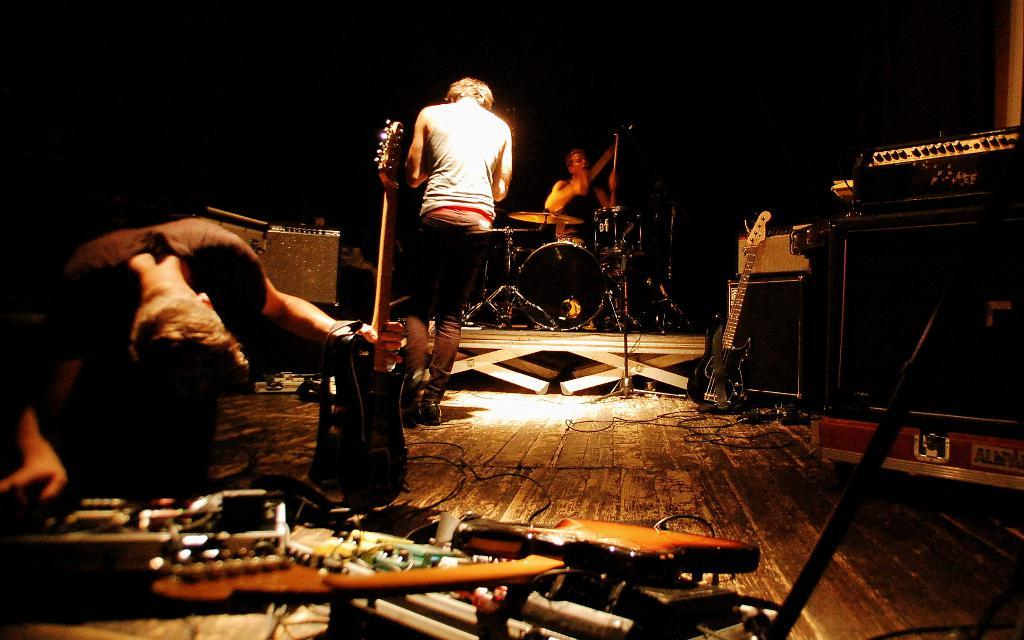How many people are performing in the image? There are three men in the image. What are the men doing in the image? The men are performing on a stage. What instrument is one of the men holding? One man is holding a guitar. What instrument is the other man playing? Another man is playing drums. Where are the clams located in the image? There are no clams present in the image. What type of lizards can be seen crawling on the stage in the image? There are no lizards present in the image. 